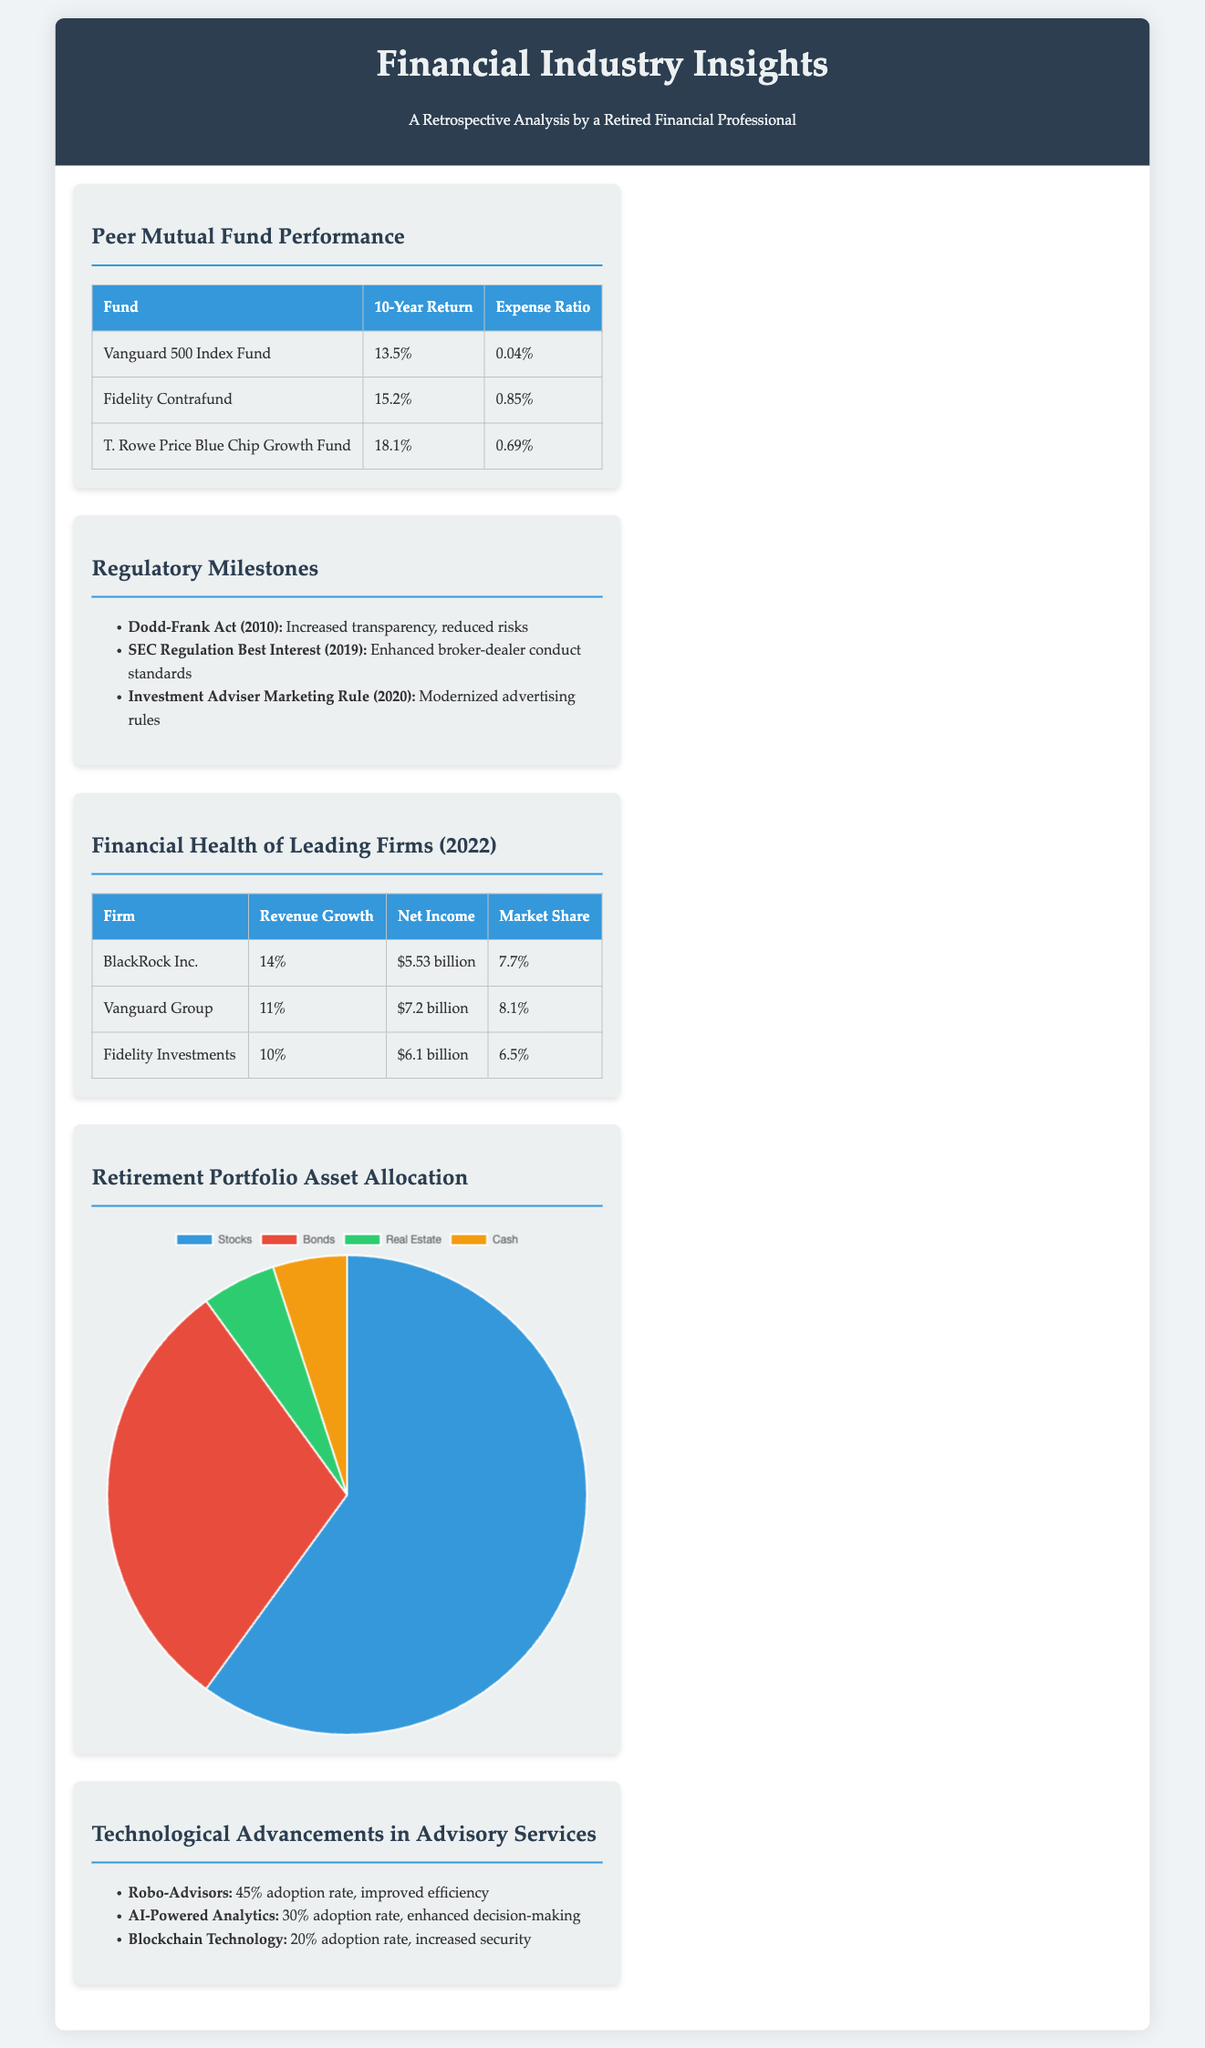What is the 10-year return for Fidelity Contrafund? The document states that Fidelity Contrafund has a 10-year return of 15.2%.
Answer: 15.2% What is the expense ratio of T. Rowe Price Blue Chip Growth Fund? According to the table, the expense ratio for T. Rowe Price Blue Chip Growth Fund is 0.69%.
Answer: 0.69% What major regulatory act was established in 2010? The document lists the Dodd-Frank Act as a major regulatory act established in 2010.
Answer: Dodd-Frank Act Which firm had the highest net income in 2022? The document shows that BlackRock Inc. had the highest net income of $5.53 billion in 2022.
Answer: BlackRock Inc What is the adoption rate of Robo-Advisors among advisory services? The document states that the adoption rate of Robo-Advisors is 45%.
Answer: 45% Which investment firm has the largest market share? Vanguard Group is noted as having the largest market share at 8.1%.
Answer: Vanguard Group What type of chart illustrates the average asset allocation? The document indicates that a pie chart displays the average asset allocation.
Answer: Pie chart How many major regulatory shifts are highlighted in the document? The document lists three major regulatory shifts in the financial services industry.
Answer: Three 